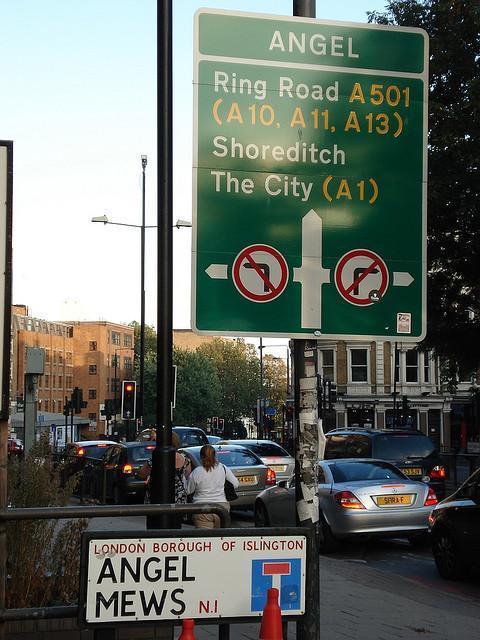How many cars are visible?
Give a very brief answer. 5. How many people are there?
Give a very brief answer. 1. 